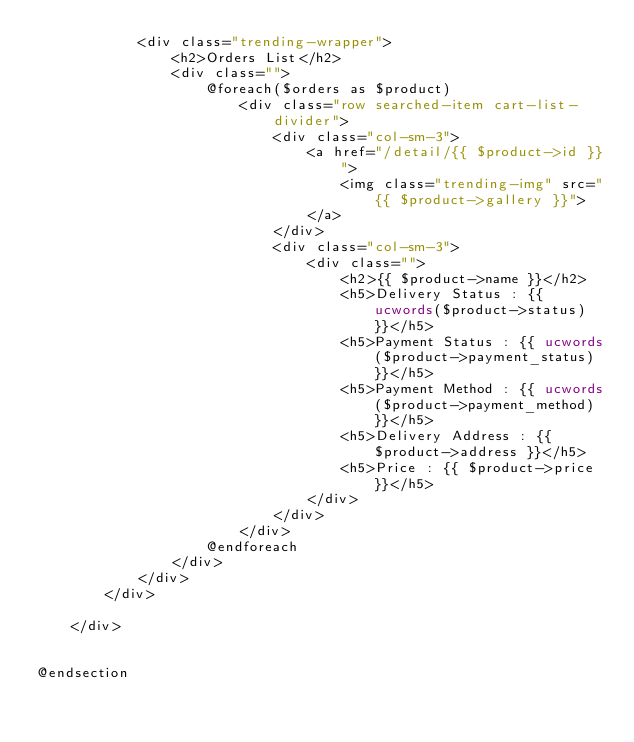<code> <loc_0><loc_0><loc_500><loc_500><_PHP_>            <div class="trending-wrapper">
                <h2>Orders List</h2>
                <div class="">
                    @foreach($orders as $product)
                        <div class="row searched-item cart-list-divider">
                            <div class="col-sm-3">
                                <a href="/detail/{{ $product->id }}">
                                    <img class="trending-img" src="{{ $product->gallery }}">
                                </a>
                            </div>
                            <div class="col-sm-3">
                                <div class="">
                                    <h2>{{ $product->name }}</h2>
                                    <h5>Delivery Status : {{ ucwords($product->status) }}</h5>
                                    <h5>Payment Status : {{ ucwords($product->payment_status) }}</h5>
                                    <h5>Payment Method : {{ ucwords($product->payment_method) }}</h5>
                                    <h5>Delivery Address : {{ $product->address }}</h5>
                                    <h5>Price : {{ $product->price }}</h5>
                                </div>
                            </div>
                        </div>
                    @endforeach
                </div>
            </div>
        </div>

    </div>


@endsection
</code> 